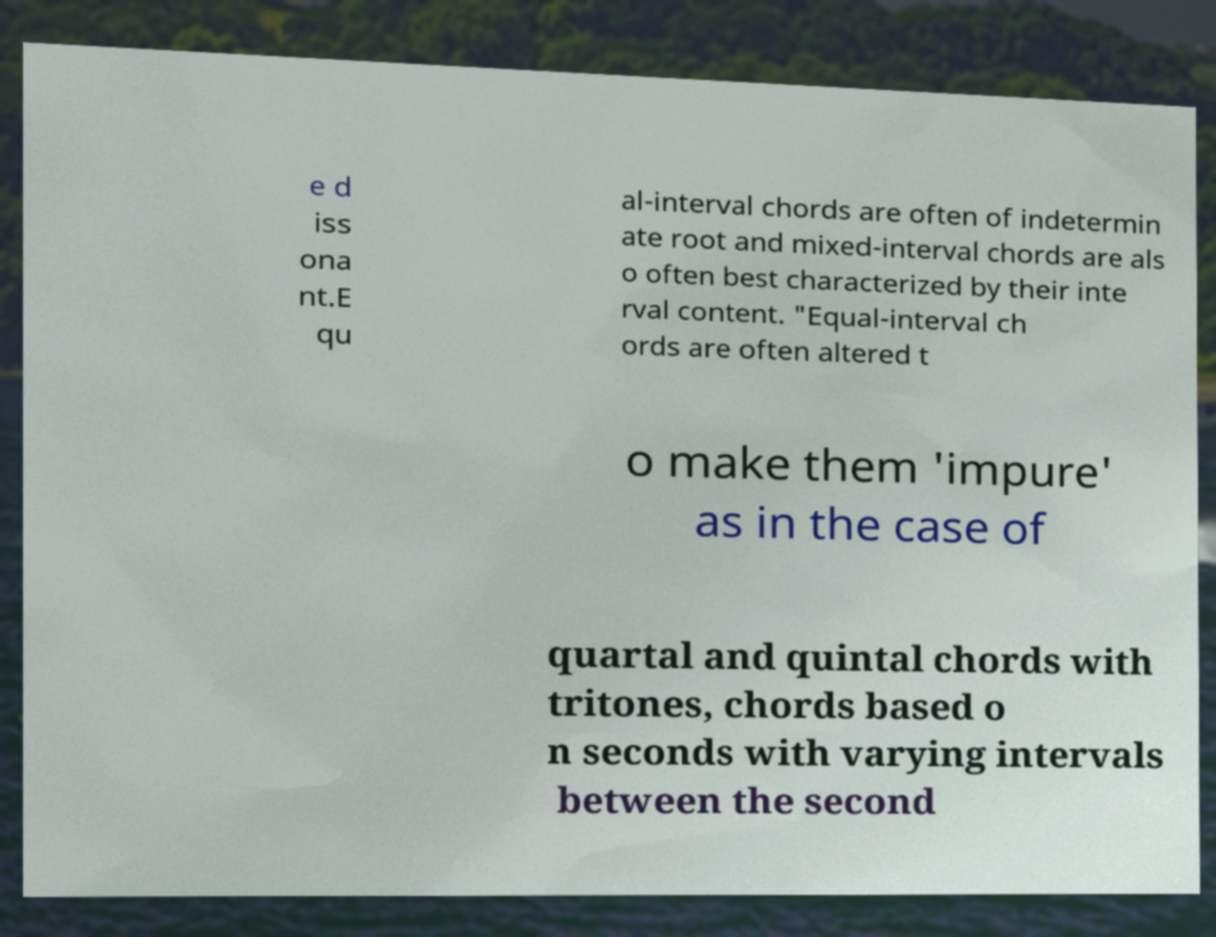Can you accurately transcribe the text from the provided image for me? e d iss ona nt.E qu al-interval chords are often of indetermin ate root and mixed-interval chords are als o often best characterized by their inte rval content. "Equal-interval ch ords are often altered t o make them 'impure' as in the case of quartal and quintal chords with tritones, chords based o n seconds with varying intervals between the second 